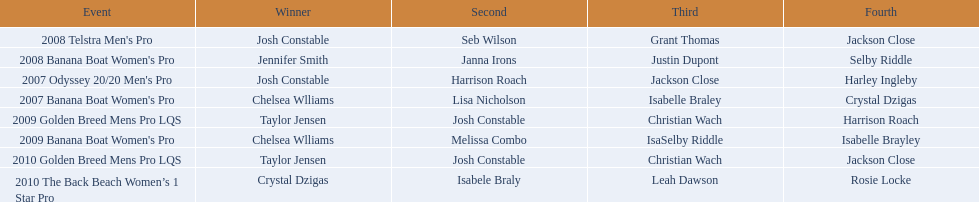In which two events did chelsea williams secure an equal rank? 2007 Banana Boat Women's Pro, 2009 Banana Boat Women's Pro. 